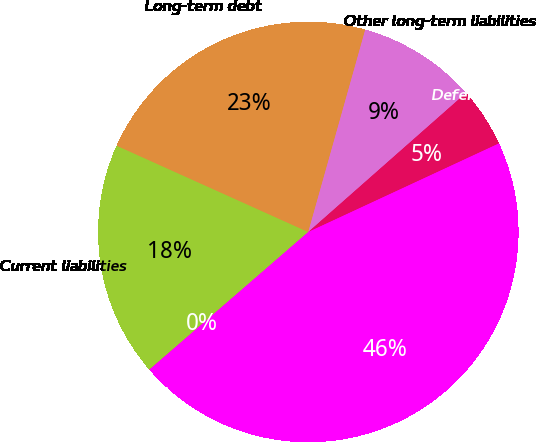Convert chart to OTSL. <chart><loc_0><loc_0><loc_500><loc_500><pie_chart><fcel>December 31<fcel>Current liabilities<fcel>Long-term debt<fcel>Other long-term liabilities<fcel>Deferred income taxes<fcel>Total liabilities<nl><fcel>0.02%<fcel>18.08%<fcel>22.63%<fcel>9.13%<fcel>4.58%<fcel>45.55%<nl></chart> 